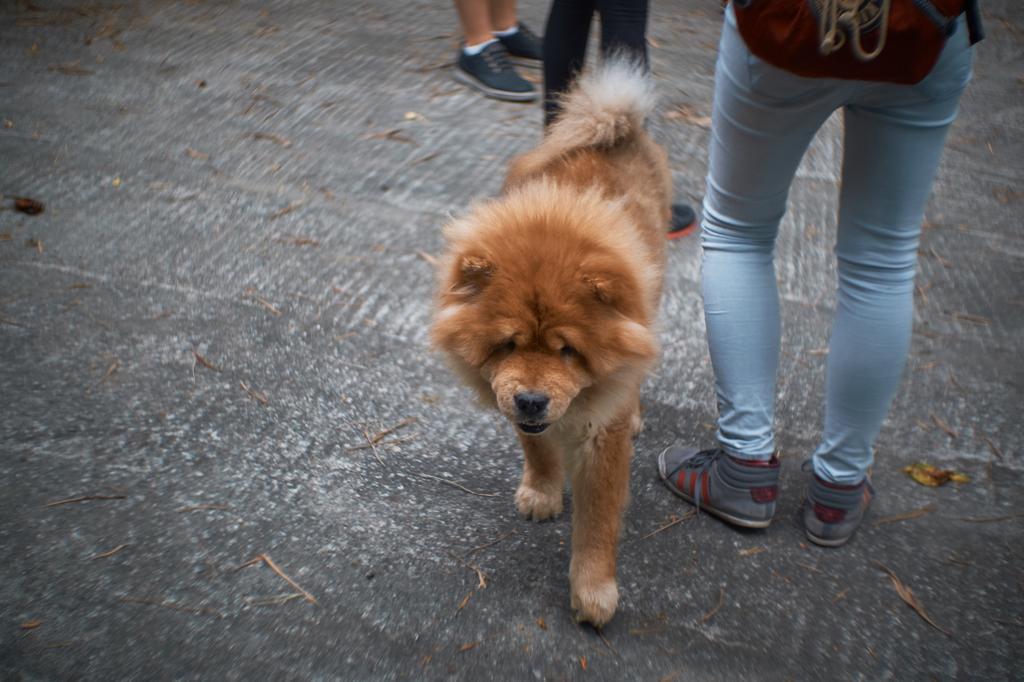Describe this image in one or two sentences. There is a brown dog. Near to the dog there are many people. Person on the right side is wearing a bag. 